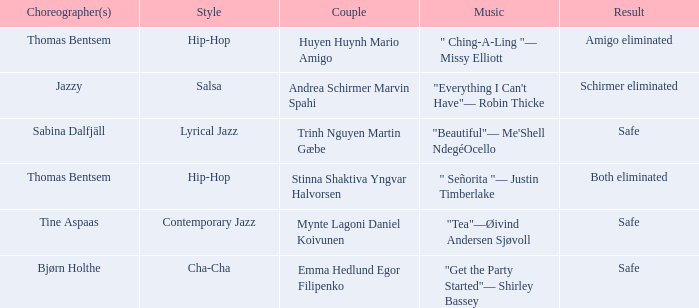What is the result of choreographer bjørn holthe? Safe. 